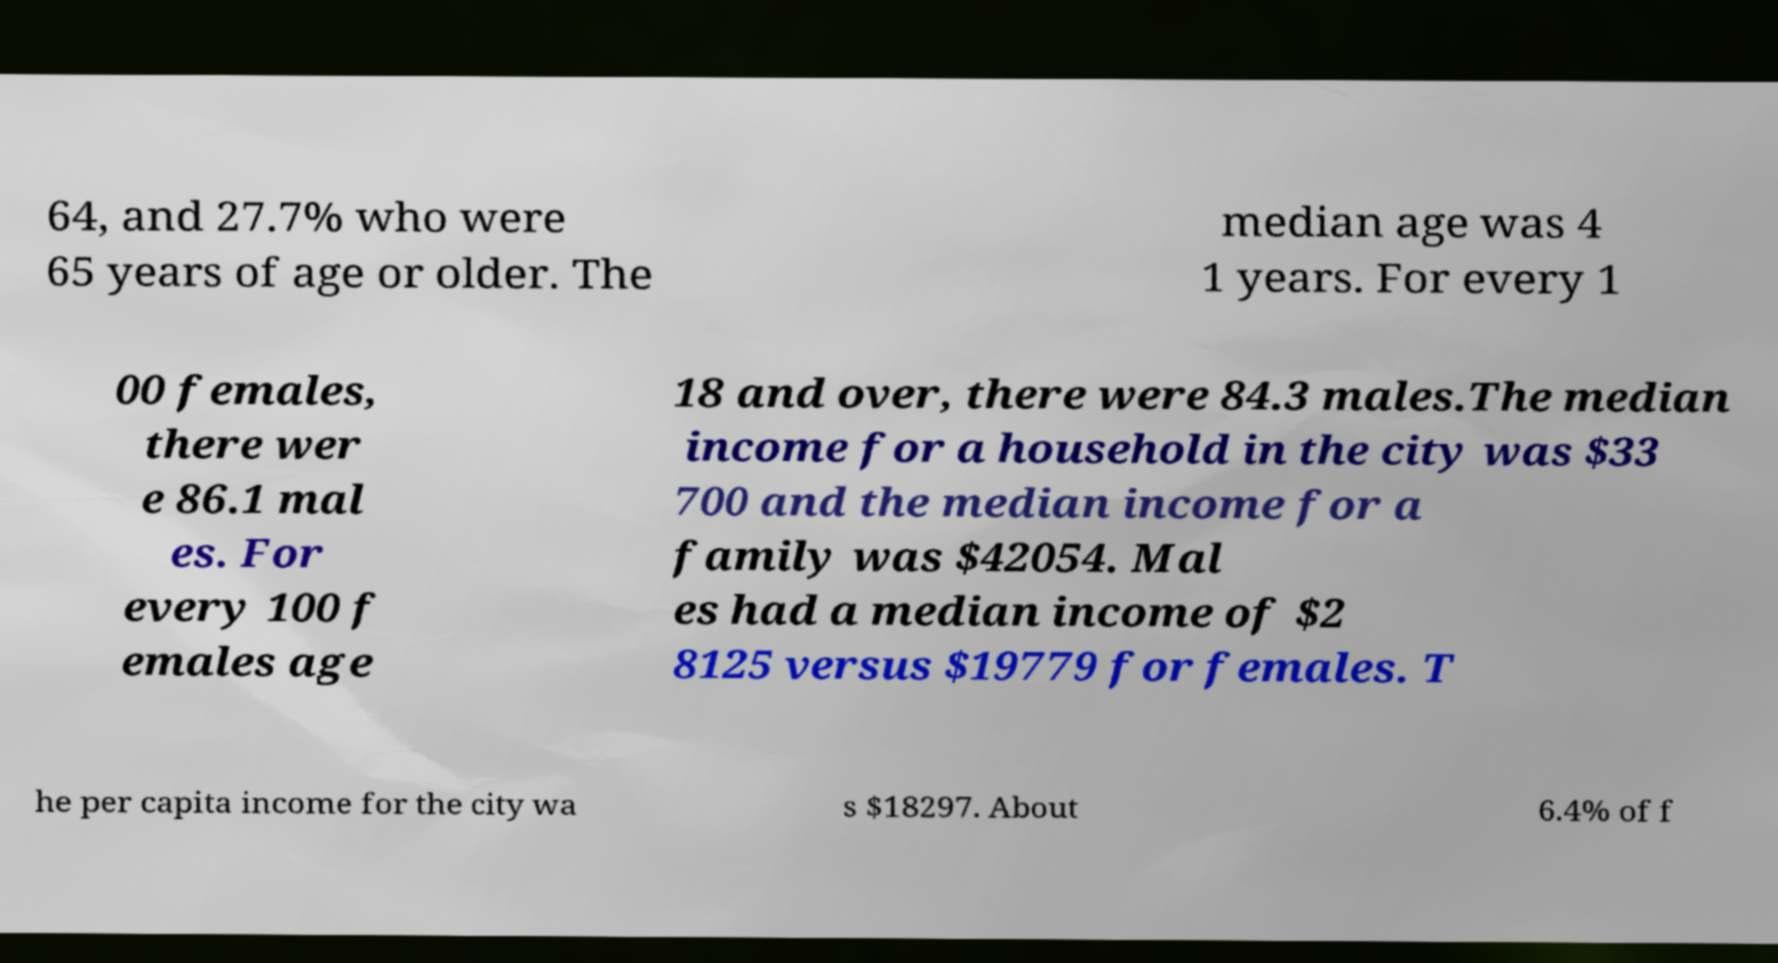Could you assist in decoding the text presented in this image and type it out clearly? 64, and 27.7% who were 65 years of age or older. The median age was 4 1 years. For every 1 00 females, there wer e 86.1 mal es. For every 100 f emales age 18 and over, there were 84.3 males.The median income for a household in the city was $33 700 and the median income for a family was $42054. Mal es had a median income of $2 8125 versus $19779 for females. T he per capita income for the city wa s $18297. About 6.4% of f 